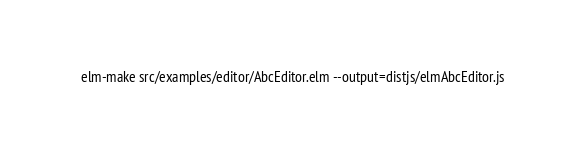<code> <loc_0><loc_0><loc_500><loc_500><_Bash_>elm-make src/examples/editor/AbcEditor.elm --output=distjs/elmAbcEditor.js
</code> 